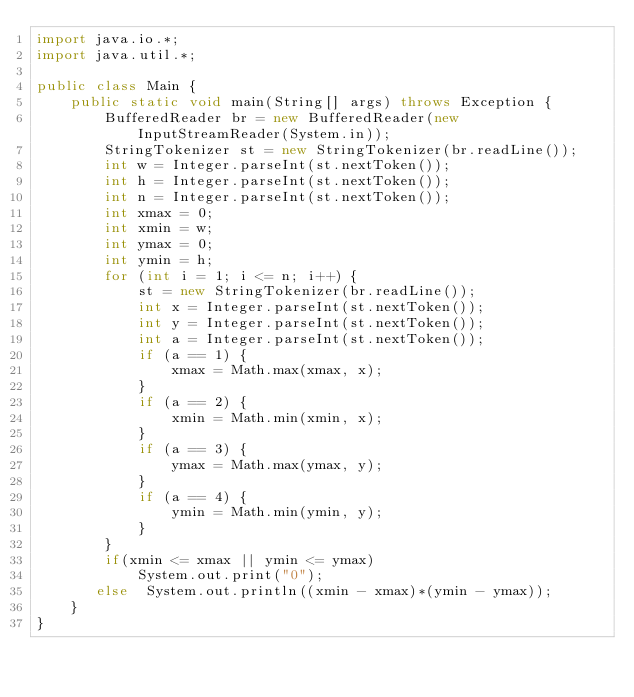<code> <loc_0><loc_0><loc_500><loc_500><_Java_>import java.io.*;
import java.util.*;
 
public class Main {
    public static void main(String[] args) throws Exception {
        BufferedReader br = new BufferedReader(new InputStreamReader(System.in));
        StringTokenizer st = new StringTokenizer(br.readLine());
        int w = Integer.parseInt(st.nextToken());
        int h = Integer.parseInt(st.nextToken());
        int n = Integer.parseInt(st.nextToken());
        int xmax = 0;
        int xmin = w;
        int ymax = 0;
        int ymin = h;
        for (int i = 1; i <= n; i++) {
            st = new StringTokenizer(br.readLine());
            int x = Integer.parseInt(st.nextToken());
            int y = Integer.parseInt(st.nextToken());
            int a = Integer.parseInt(st.nextToken());
            if (a == 1) {
                xmax = Math.max(xmax, x);
            }
            if (a == 2) {
                xmin = Math.min(xmin, x);
            }
            if (a == 3) {
                ymax = Math.max(ymax, y);
            }
            if (a == 4) {
                ymin = Math.min(ymin, y);
            }
        }
        if(xmin <= xmax || ymin <= ymax)
            System.out.print("0");
       else  System.out.println((xmin - xmax)*(ymin - ymax));
    }
}</code> 